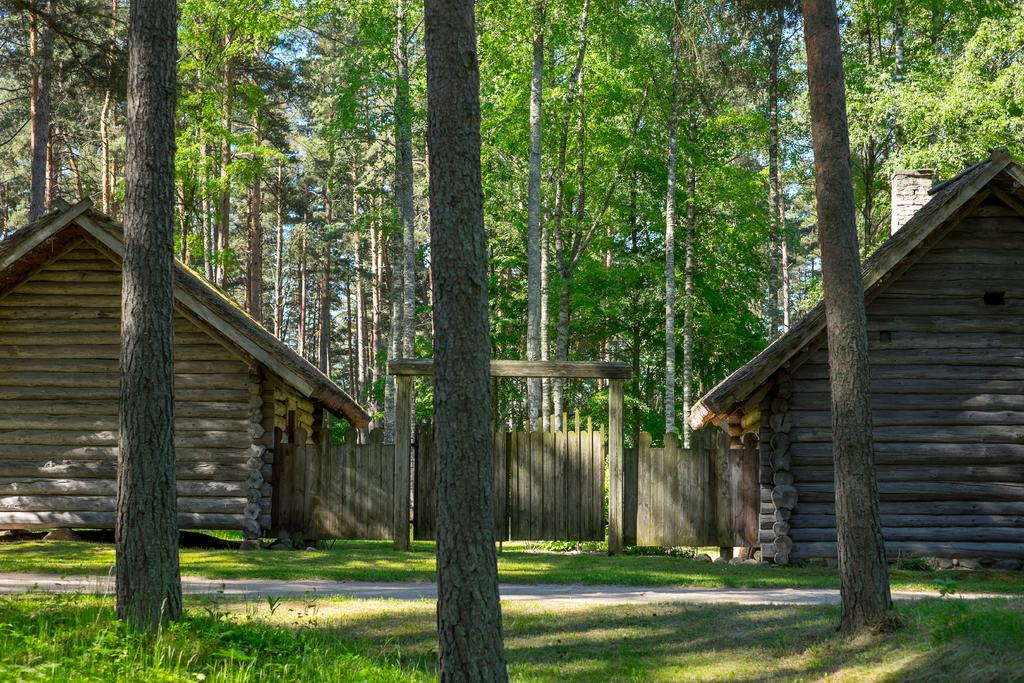What is located in the center of the image? There are houses in the center of the image. What can be seen in the background of the image? There are trees in the background of the image. What is at the bottom of the image? There is a road and grass at the bottom of the image. What type of birthday celebration is happening in the image? There is no indication of a birthday celebration in the image. What is the current temperature in the image? The image does not provide information about the temperature. 